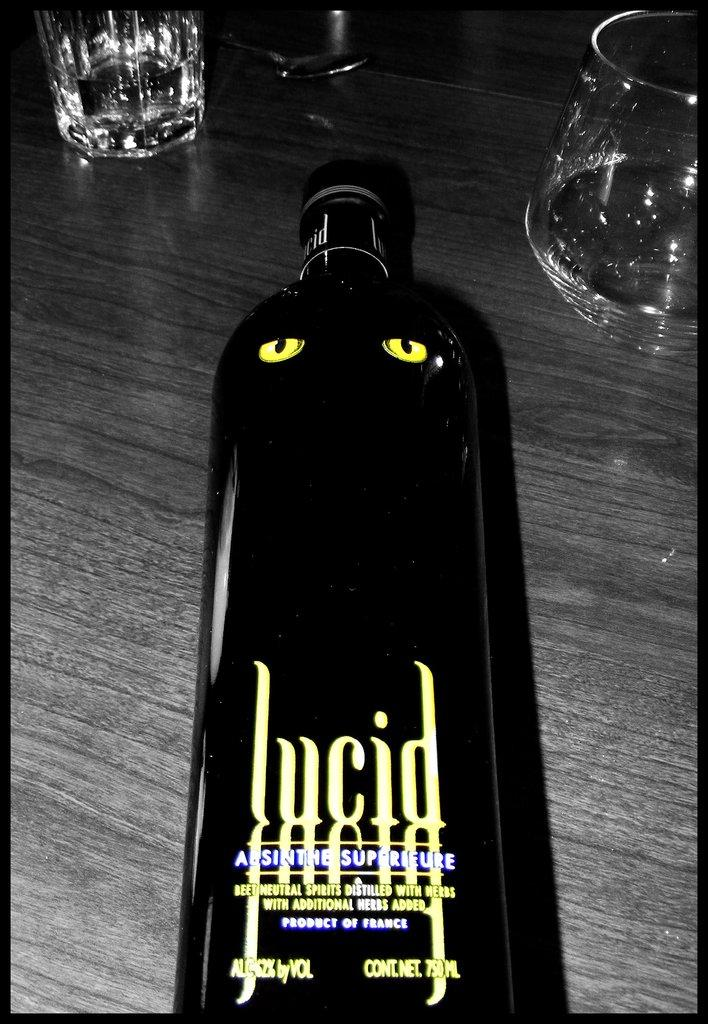What is located in the foreground of the image? There is a bottle in the foreground of the image. What is the bottle placed on? The bottle is on a wooden surface. What other objects can be seen in the image? There are glasses visible at the top of the image. What type of tax is being discussed in the image? There is no discussion of tax in the image; it features a bottle on a wooden surface and glasses. What type of cork is used to seal the bottle in the image? The image does not show the bottle's cork, so it cannot be determined from the image. 